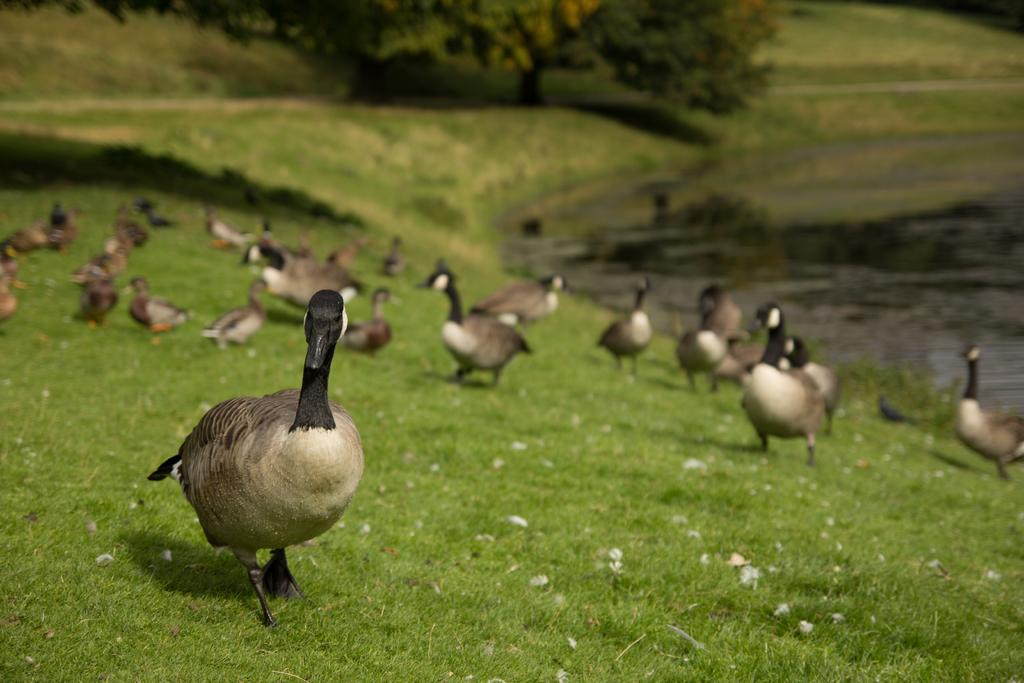What animals can be seen in the image? There are ducks on the grass in the image. What can be seen in the background of the image? There are trees and water visible in the background of the image. What type of vegetation is present in the image? There is grass in the image. What type of doll is being crushed by the ducks in the image? There is no doll present in the image, and the ducks are not crushing anything. 